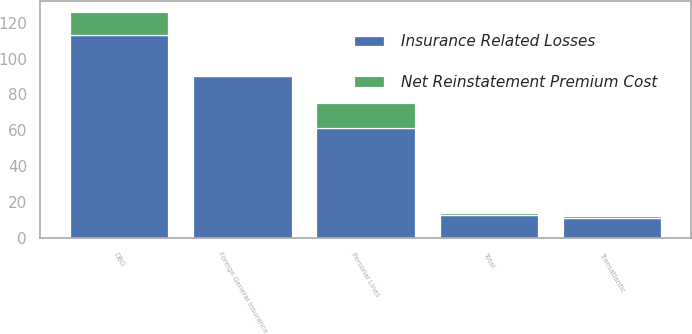Convert chart to OTSL. <chart><loc_0><loc_0><loc_500><loc_500><stacked_bar_chart><ecel><fcel>DBG<fcel>Transatlantic<fcel>Personal Lines<fcel>Foreign General Insurance<fcel>Total<nl><fcel>Insurance Related Losses<fcel>113<fcel>11<fcel>61<fcel>90<fcel>13<nl><fcel>Net Reinstatement Premium Cost<fcel>13<fcel>1<fcel>14<fcel>1<fcel>1<nl></chart> 